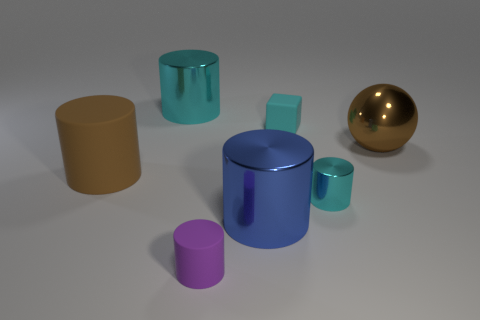There is a thing that is the same color as the shiny sphere; what is its shape?
Give a very brief answer. Cylinder. Is there another big metal thing of the same shape as the purple thing?
Give a very brief answer. Yes. There is a large object that is on the right side of the small matte cube; is its shape the same as the big brown thing that is on the left side of the big brown ball?
Offer a terse response. No. What is the shape of the large shiny thing that is left of the brown shiny thing and behind the small shiny object?
Give a very brief answer. Cylinder. Are there any other metallic things of the same size as the brown metallic thing?
Your answer should be very brief. Yes. There is a ball; is it the same color as the tiny rubber object on the left side of the large blue shiny cylinder?
Give a very brief answer. No. What is the material of the cyan cube?
Provide a short and direct response. Rubber. The large metal cylinder in front of the large brown metal object is what color?
Keep it short and to the point. Blue. How many cubes are the same color as the tiny shiny cylinder?
Offer a terse response. 1. What number of things are on the left side of the small cube and on the right side of the brown cylinder?
Provide a short and direct response. 3. 